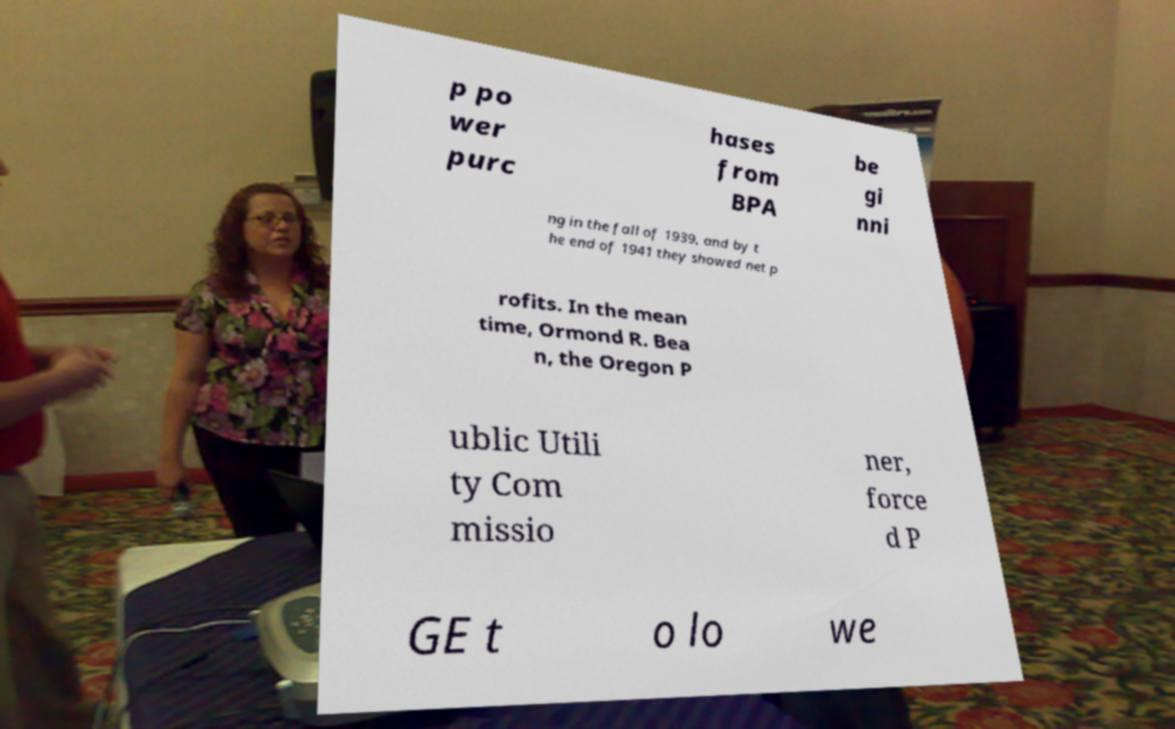Please read and relay the text visible in this image. What does it say? p po wer purc hases from BPA be gi nni ng in the fall of 1939, and by t he end of 1941 they showed net p rofits. In the mean time, Ormond R. Bea n, the Oregon P ublic Utili ty Com missio ner, force d P GE t o lo we 